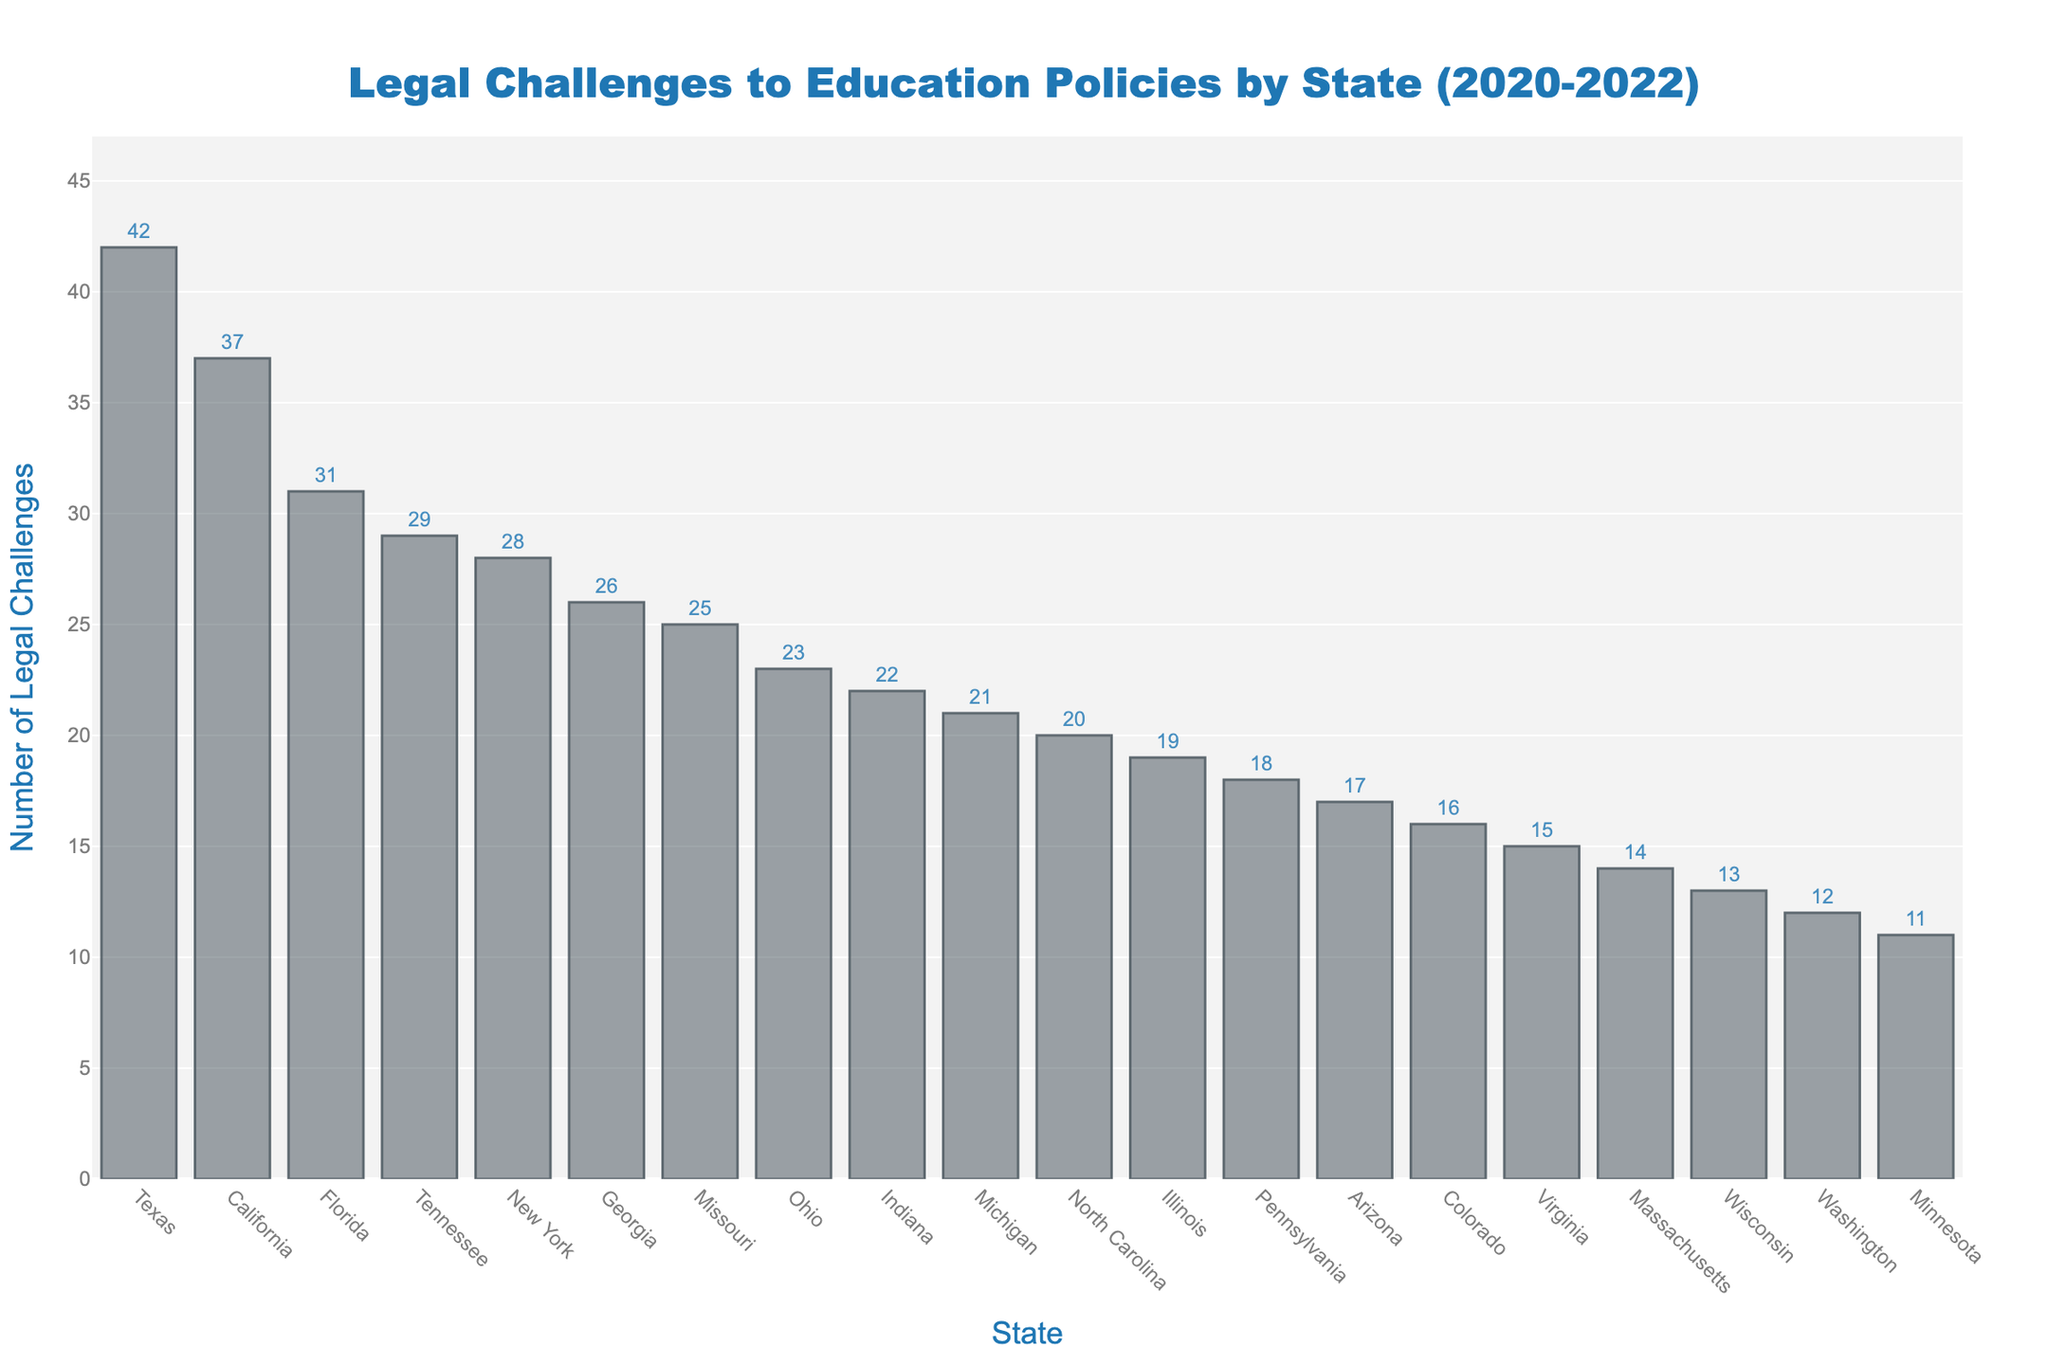Which state had the highest number of legal challenges to education policies between 2020 and 2022? The bar representing Texas is the tallest in the chart, showing it had the highest number of legal challenges among the states.
Answer: Texas What is the difference in the number of legal challenges between Texas and California? Texas had 42 legal challenges, while California had 37. The difference is calculated as 42 - 37.
Answer: 5 Which states had fewer than 15 legal challenges? The bars for Massachusetts, Washington, Wisconsin, and Minnesota are below the 15 mark on the y-axis.
Answer: Massachusetts, Washington, Wisconsin, Minnesota By how much does the number of legal challenges in New York exceed that in Virginia? New York had 28 legal challenges, and Virginia had 15. The difference is calculated as 28 - 15.
Answer: 13 What is the combined total of legal challenges in Michigan, Ohio, and Georgia? Michigan had 21, Ohio had 23, and Georgia had 26 challenges. The combined total is 21 + 23 + 26.
Answer: 70 Which state had exactly 20 legal challenges? The bar for North Carolina is at the 20 mark on the y-axis.
Answer: North Carolina How many states had more than 30 legal challenges? The bars for Texas, California, Florida, and Tennessee are above the 30 mark.
Answer: 4 Among Illinois, Pennsylvania, and Indiana, which state had the least number of legal challenges? Illinois had 19 challenges, Pennsylvania had 18, and Indiana had 22. Pennsylvania had the least.
Answer: Pennsylvania What is the average number of legal challenges across all the states? Sum all the challenges and divide by the number of states: (37 + 42 + 31 + 28 + 19 + 23 + 18 + 21 + 15 + 26 + 14 + 20 + 29 + 17 + 12 + 16 + 22 + 13 + 11 + 25) / 20 = 26. Answer is the closest integer calculated.
Answer: 22 How does the number of legal challenges in Tennessee compare to that in Arizona? Tennessee had 29 legal challenges, and Arizona had 17. Comparing the two, Tennessee had more.
Answer: Tennessee had more 